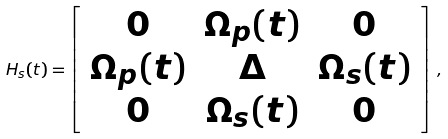Convert formula to latex. <formula><loc_0><loc_0><loc_500><loc_500>H _ { s } ( t ) = \left [ \begin{array} { c c c } 0 & \Omega _ { p } ( t ) & 0 \\ \Omega _ { p } ( t ) & \Delta & \Omega _ { s } ( t ) \\ 0 & \Omega _ { s } ( t ) & 0 \\ \end{array} \right ] \, ,</formula> 